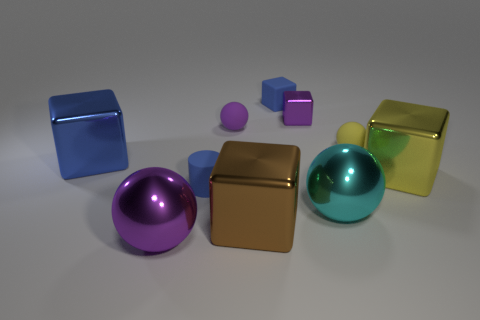Subtract all small metallic cubes. How many cubes are left? 4 Subtract 2 cubes. How many cubes are left? 3 Subtract all yellow cubes. How many cubes are left? 4 Subtract all cyan blocks. Subtract all blue balls. How many blocks are left? 5 Subtract all cylinders. How many objects are left? 9 Subtract all small green matte balls. Subtract all big blocks. How many objects are left? 7 Add 5 purple blocks. How many purple blocks are left? 6 Add 1 big brown rubber balls. How many big brown rubber balls exist? 1 Subtract 1 yellow cubes. How many objects are left? 9 